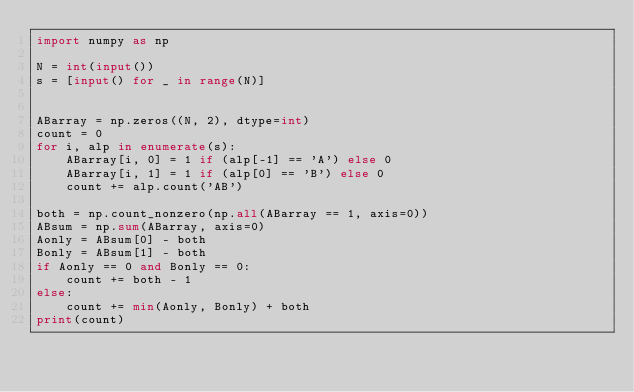Convert code to text. <code><loc_0><loc_0><loc_500><loc_500><_Python_>import numpy as np

N = int(input())
s = [input() for _ in range(N)]


ABarray = np.zeros((N, 2), dtype=int)
count = 0
for i, alp in enumerate(s):
    ABarray[i, 0] = 1 if (alp[-1] == 'A') else 0
    ABarray[i, 1] = 1 if (alp[0] == 'B') else 0
    count += alp.count('AB')

both = np.count_nonzero(np.all(ABarray == 1, axis=0))
ABsum = np.sum(ABarray, axis=0)
Aonly = ABsum[0] - both
Bonly = ABsum[1] - both
if Aonly == 0 and Bonly == 0:
    count += both - 1
else:
    count += min(Aonly, Bonly) + both
print(count)
</code> 